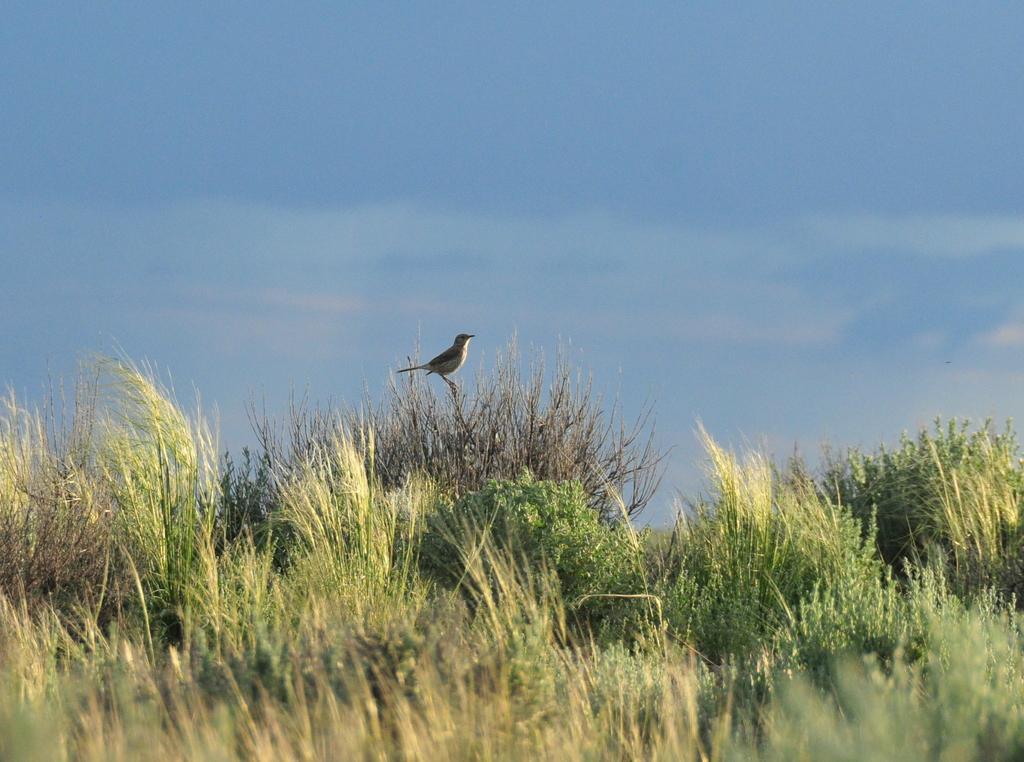What type of animal is in the image? There is a bird in the image. Where is the bird located? The bird is on a plant. What type of vegetation is at the bottom of the image? There is grass at the bottom of the image. What can be seen in the background of the image? The sky is visible in the background of the image. What song is the bird singing in the image? There is no indication in the image that the bird is singing a song, so it cannot be determined from the picture. 